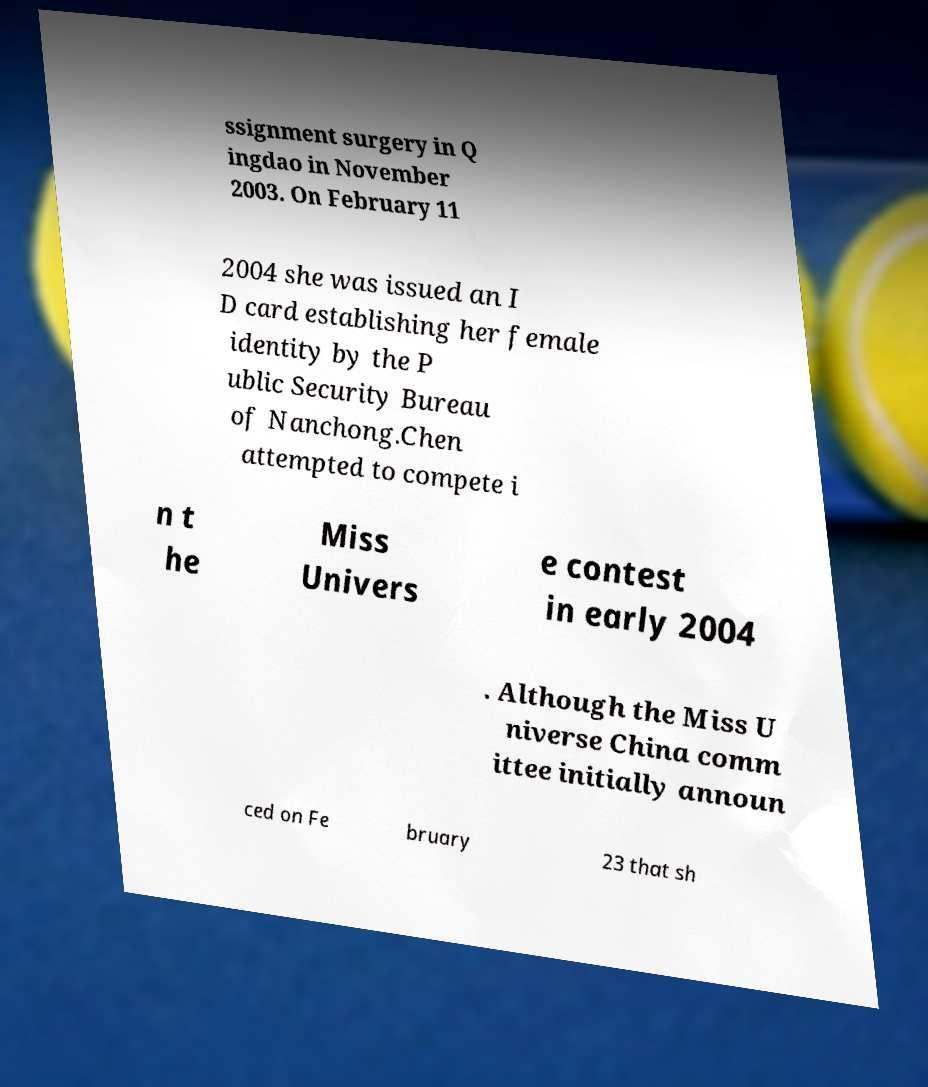Can you accurately transcribe the text from the provided image for me? ssignment surgery in Q ingdao in November 2003. On February 11 2004 she was issued an I D card establishing her female identity by the P ublic Security Bureau of Nanchong.Chen attempted to compete i n t he Miss Univers e contest in early 2004 . Although the Miss U niverse China comm ittee initially announ ced on Fe bruary 23 that sh 